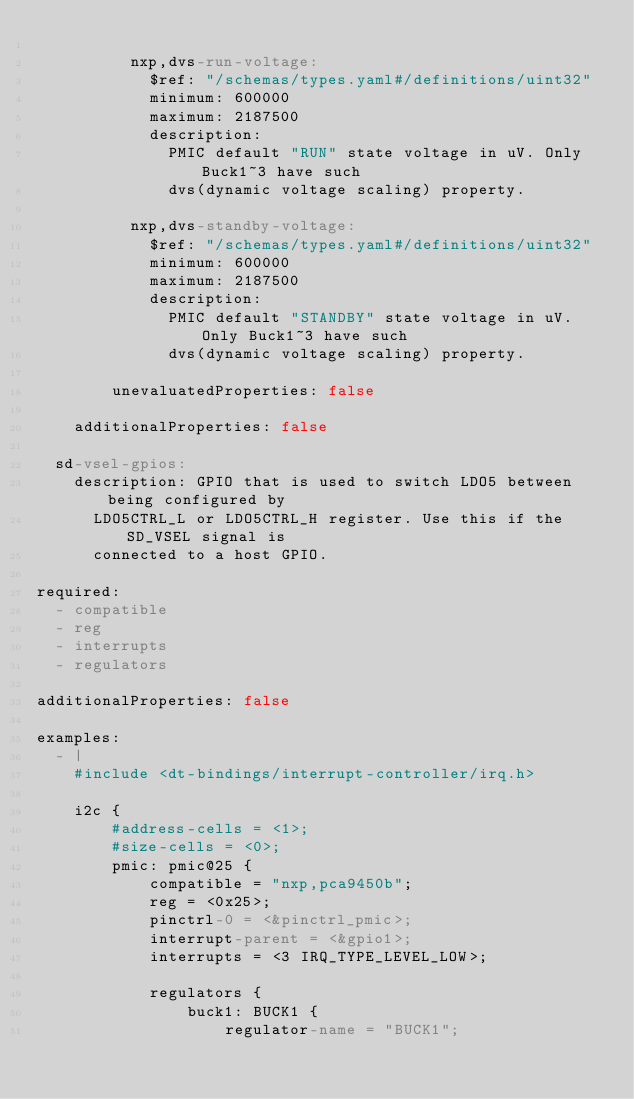Convert code to text. <code><loc_0><loc_0><loc_500><loc_500><_YAML_>
          nxp,dvs-run-voltage:
            $ref: "/schemas/types.yaml#/definitions/uint32"
            minimum: 600000
            maximum: 2187500
            description:
              PMIC default "RUN" state voltage in uV. Only Buck1~3 have such
              dvs(dynamic voltage scaling) property.

          nxp,dvs-standby-voltage:
            $ref: "/schemas/types.yaml#/definitions/uint32"
            minimum: 600000
            maximum: 2187500
            description:
              PMIC default "STANDBY" state voltage in uV. Only Buck1~3 have such
              dvs(dynamic voltage scaling) property.

        unevaluatedProperties: false

    additionalProperties: false

  sd-vsel-gpios:
    description: GPIO that is used to switch LDO5 between being configured by
      LDO5CTRL_L or LDO5CTRL_H register. Use this if the SD_VSEL signal is
      connected to a host GPIO.

required:
  - compatible
  - reg
  - interrupts
  - regulators

additionalProperties: false

examples:
  - |
    #include <dt-bindings/interrupt-controller/irq.h>

    i2c {
        #address-cells = <1>;
        #size-cells = <0>;
        pmic: pmic@25 {
            compatible = "nxp,pca9450b";
            reg = <0x25>;
            pinctrl-0 = <&pinctrl_pmic>;
            interrupt-parent = <&gpio1>;
            interrupts = <3 IRQ_TYPE_LEVEL_LOW>;

            regulators {
                buck1: BUCK1 {
                    regulator-name = "BUCK1";</code> 